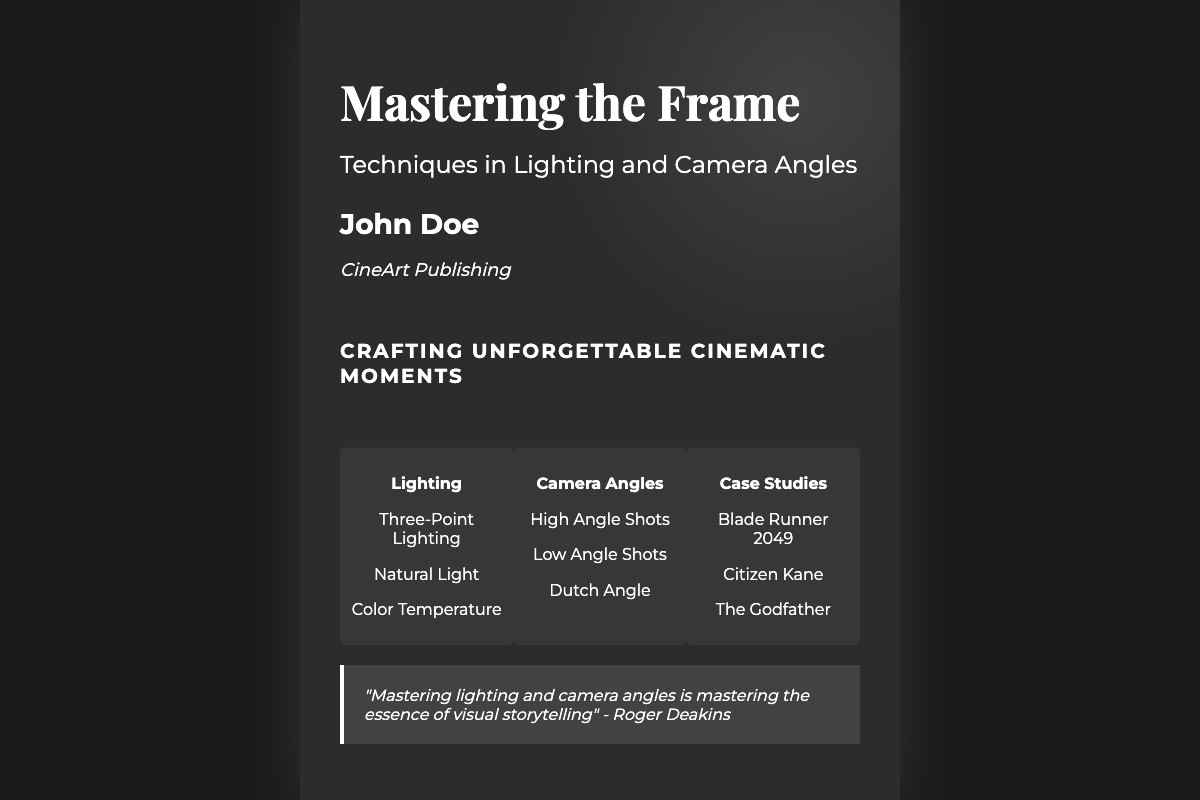what is the title of the book? The title of the book is prominently displayed on the cover.
Answer: Mastering the Frame who is the author of the book? The author's name is given near the title on the cover.
Answer: John Doe what is the subtitle of the book? The subtitle provides additional context about the book’s content.
Answer: Techniques in Lighting and Camera Angles which publisher released this book? The publisher's name appears at the bottom of the cover.
Answer: CineArt Publishing what is one of the lighting techniques mentioned? The sections provide details about various techniques showcased in the book.
Answer: Three-Point Lighting name one camera angle technique covered in the book. The camera angles section lists different types of angles used in cinematography.
Answer: High Angle Shots what is one of the case studies featured? The case studies section highlights notable films related to the content.
Answer: Blade Runner 2049 what is the tagline of the book? The tagline summarizes the book's focus and intention.
Answer: Crafting Unforgettable Cinematic Moments who is quoted on the book cover? The quote at the bottom attributes a statement to a notable figure in cinematography.
Answer: Roger Deakins 